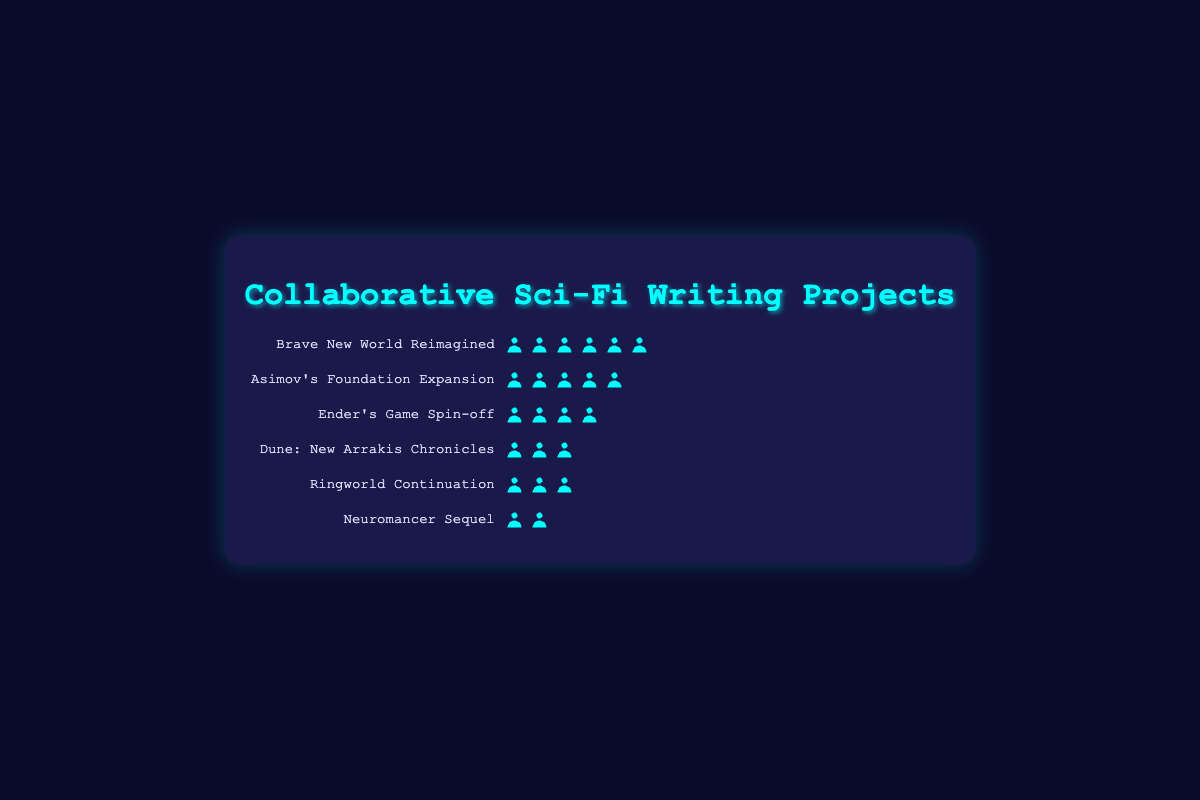How many writers are involved in the "Ender's Game Spin-off" project? Count the number of writer silhouettes for the "Ender's Game Spin-off" project; there are 4 icons.
Answer: 4 Which project has the most writers? Compare the number of writer silhouettes in each project; "Brave New World Reimagined" has the most with 6 writers.
Answer: Brave New World Reimagined Are there any projects with exactly 3 writers? If so, which ones? Identify projects with 3 writer silhouettes; "Dune: New Arrakis Chronicles" and "Ringworld Continuation" both have 3 writers.
Answer: Dune: New Arrakis Chronicles, Ringworld Continuation What is the total number of writers across all projects? Add the number of writers in each project: 6 (Brave New World Reimagined) + 5 (Asimov's Foundation Expansion) + 4 (Ender's Game Spin-off) + 3 (Dune: New Arrakis Chronicles) + 3 (Ringworld Continuation) + 2 (Neuromancer Sequel); the sum is 23.
Answer: 23 Which project has the fewest writers? Identify the project with the least number of writer silhouettes; "Neuromancer Sequel" has the fewest with 2 writers.
Answer: Neuromancer Sequel Is the number of writers in "Dune: New Arrakis Chronicles" greater than in "Neuromancer Sequel"? Compare the number of writer silhouettes in both projects; "Dune: New Arrakis Chronicles" has 3 writers and "Neuromancer Sequel" has 2 writers.
Answer: Yes How many more writers are in "Asimov's Foundation Expansion" than in "Neuromancer Sequel"? Calculate the difference in the number of writers: 5 (Asimov's Foundation Expansion) - 2 (Neuromancer Sequel) = 3.
Answer: 3 List the projects in descending order of the number of writers. Sort the projects based on the number of writer silhouettes: 1. "Brave New World Reimagined" (6), 2. "Asimov's Foundation Expansion" (5), 3. "Ender's Game Spin-off" (4), 4. "Dune: New Arrakis Chronicles" (3), 5. "Ringworld Continuation" (3), 6. "Neuromancer Sequel" (2).
Answer: Brave New World Reimagined, Asimov's Foundation Expansion, Ender's Game Spin-off, Dune: New Arrakis Chronicles, Ringworld Continuation, Neuromancer Sequel 